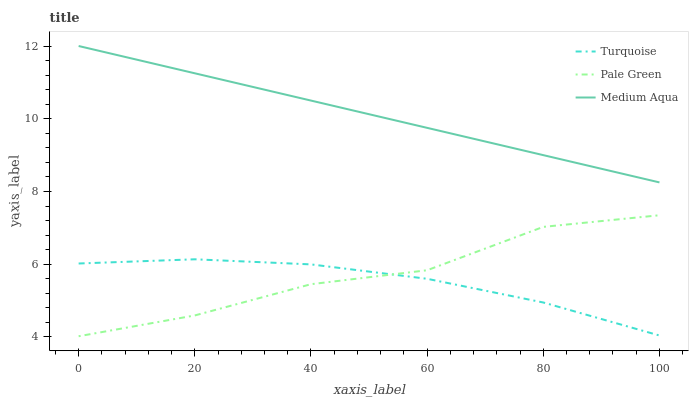Does Turquoise have the minimum area under the curve?
Answer yes or no. Yes. Does Medium Aqua have the maximum area under the curve?
Answer yes or no. Yes. Does Pale Green have the minimum area under the curve?
Answer yes or no. No. Does Pale Green have the maximum area under the curve?
Answer yes or no. No. Is Medium Aqua the smoothest?
Answer yes or no. Yes. Is Pale Green the roughest?
Answer yes or no. Yes. Is Pale Green the smoothest?
Answer yes or no. No. Is Medium Aqua the roughest?
Answer yes or no. No. Does Pale Green have the lowest value?
Answer yes or no. Yes. Does Medium Aqua have the lowest value?
Answer yes or no. No. Does Medium Aqua have the highest value?
Answer yes or no. Yes. Does Pale Green have the highest value?
Answer yes or no. No. Is Turquoise less than Medium Aqua?
Answer yes or no. Yes. Is Medium Aqua greater than Turquoise?
Answer yes or no. Yes. Does Pale Green intersect Turquoise?
Answer yes or no. Yes. Is Pale Green less than Turquoise?
Answer yes or no. No. Is Pale Green greater than Turquoise?
Answer yes or no. No. Does Turquoise intersect Medium Aqua?
Answer yes or no. No. 